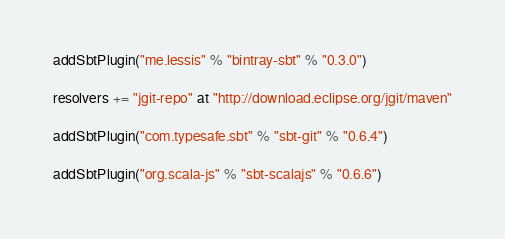<code> <loc_0><loc_0><loc_500><loc_500><_Scala_>
addSbtPlugin("me.lessis" % "bintray-sbt" % "0.3.0")

resolvers += "jgit-repo" at "http://download.eclipse.org/jgit/maven"

addSbtPlugin("com.typesafe.sbt" % "sbt-git" % "0.6.4")

addSbtPlugin("org.scala-js" % "sbt-scalajs" % "0.6.6")</code> 